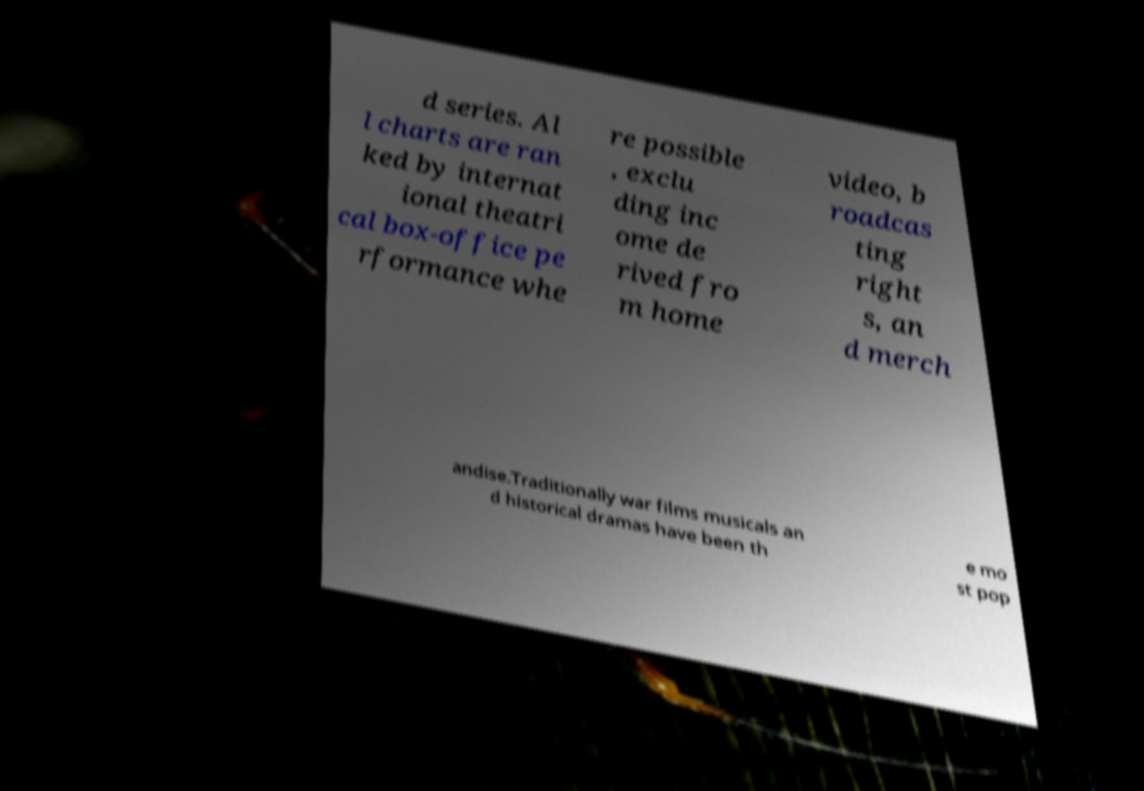Could you extract and type out the text from this image? d series. Al l charts are ran ked by internat ional theatri cal box-office pe rformance whe re possible , exclu ding inc ome de rived fro m home video, b roadcas ting right s, an d merch andise.Traditionally war films musicals an d historical dramas have been th e mo st pop 